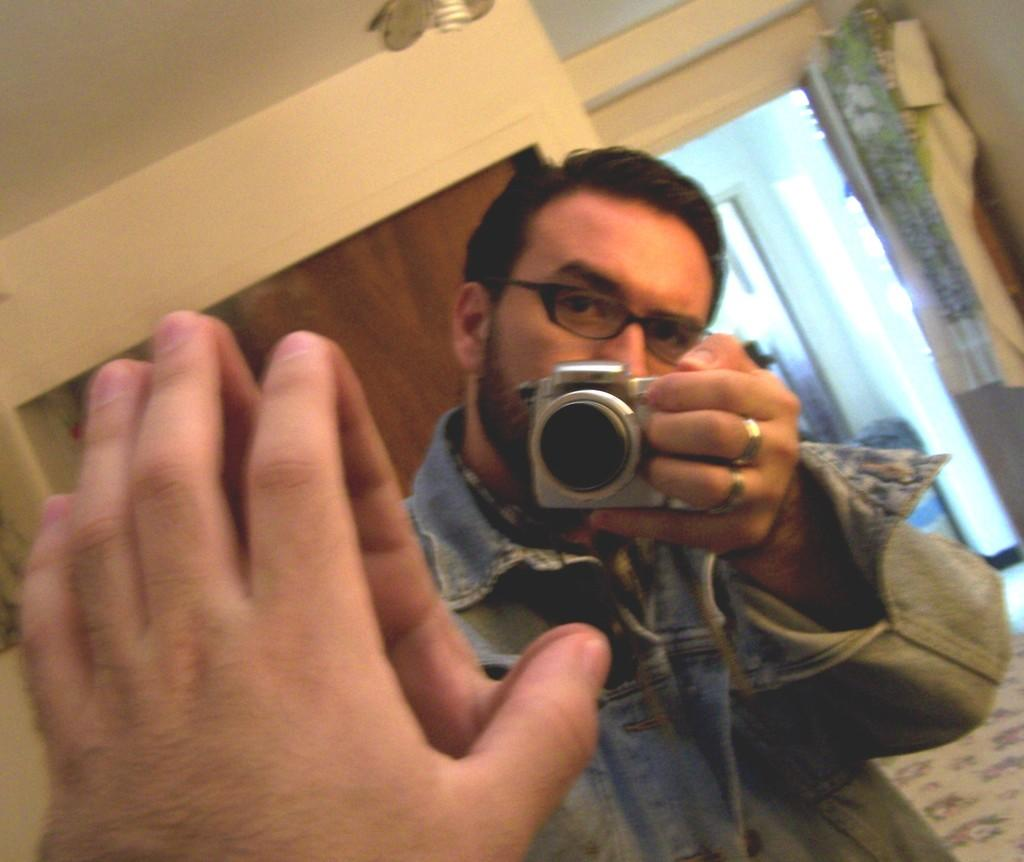What is the main subject of the image? The main subject of the image is a man. What is the man wearing in the image? The man is wearing a shirt in the image. What is the man doing in the image? The man is standing and taking a picture in front of a mirror in the image. What object is the man holding in his hand? The man is holding a camera in his hand in the image. What can be seen in the top right corner of the image? There is a door in the top right corner of the image. What type of calculator is the man using to take the picture in the image? There is no calculator present in the image; the man is using a camera to take the picture. What is the current temperature in the room where the man is taking the picture? The provided facts do not give any information about the temperature in the room, so it cannot be determined from the image. 